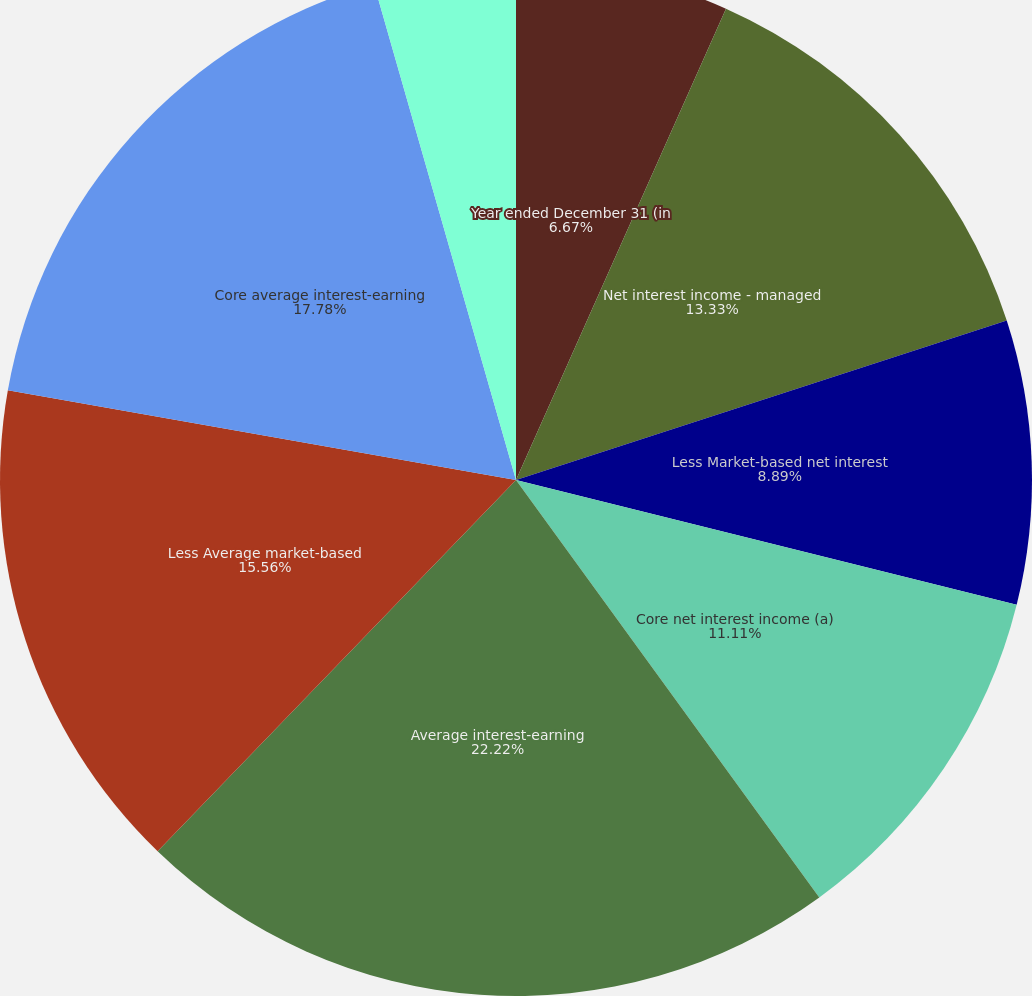<chart> <loc_0><loc_0><loc_500><loc_500><pie_chart><fcel>Year ended December 31 (in<fcel>Net interest income - managed<fcel>Less Market-based net interest<fcel>Core net interest income (a)<fcel>Average interest-earning<fcel>Less Average market-based<fcel>Core average interest-earning<fcel>Net interest yield on<fcel>Core net interest yield on<nl><fcel>6.67%<fcel>13.33%<fcel>8.89%<fcel>11.11%<fcel>22.22%<fcel>15.56%<fcel>17.78%<fcel>0.0%<fcel>4.44%<nl></chart> 